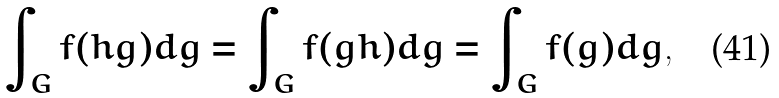<formula> <loc_0><loc_0><loc_500><loc_500>\int _ { G } f ( h g ) d g = \int _ { G } f ( g h ) d g = \int _ { G } f ( g ) d g ,</formula> 